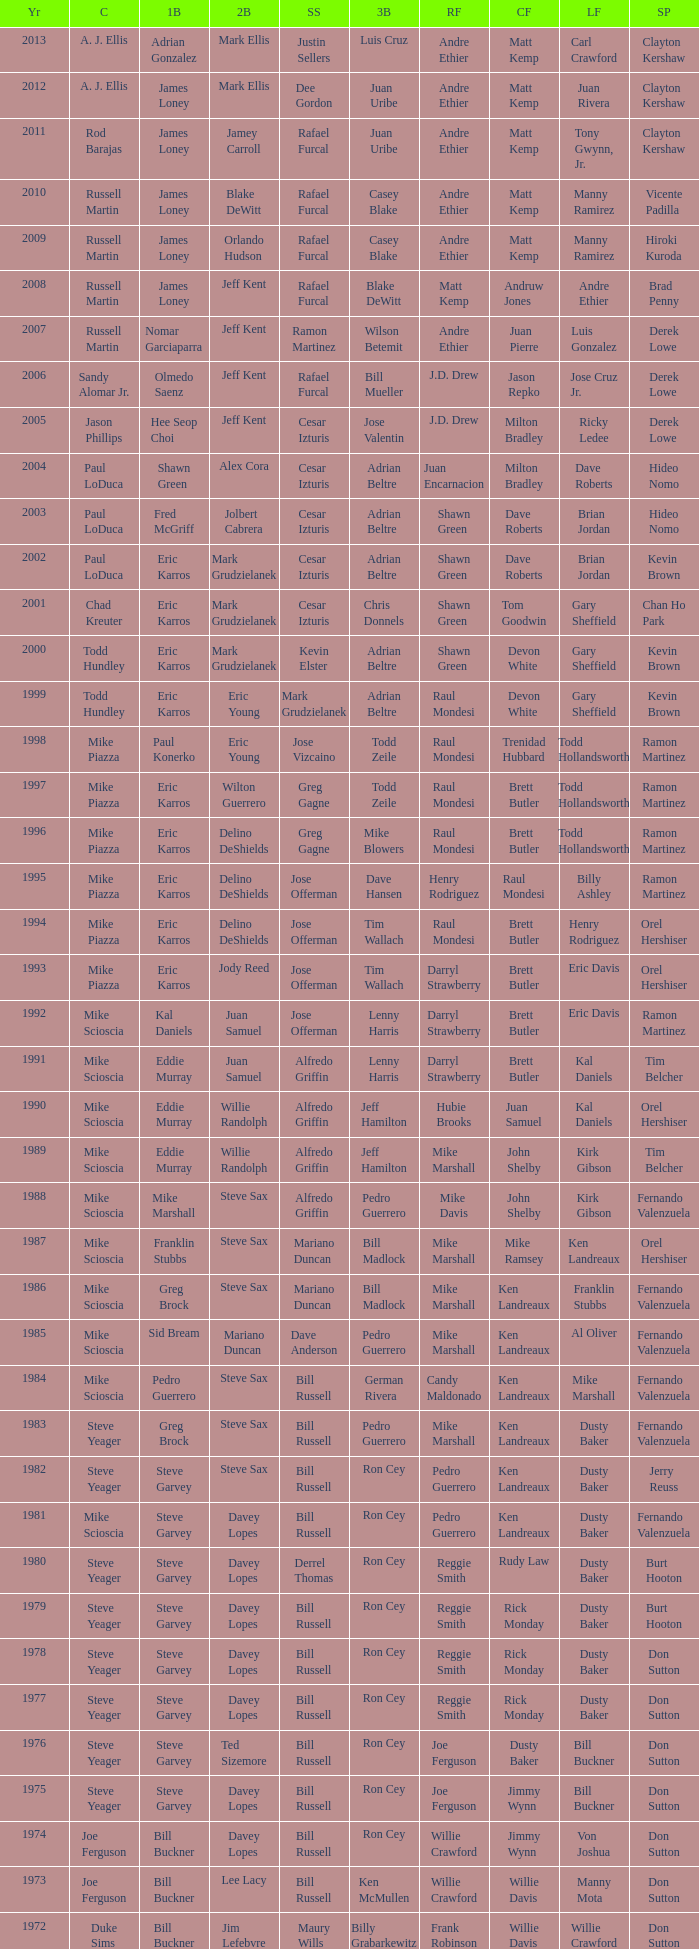Who played 2nd base when nomar garciaparra was at 1st base? Jeff Kent. 